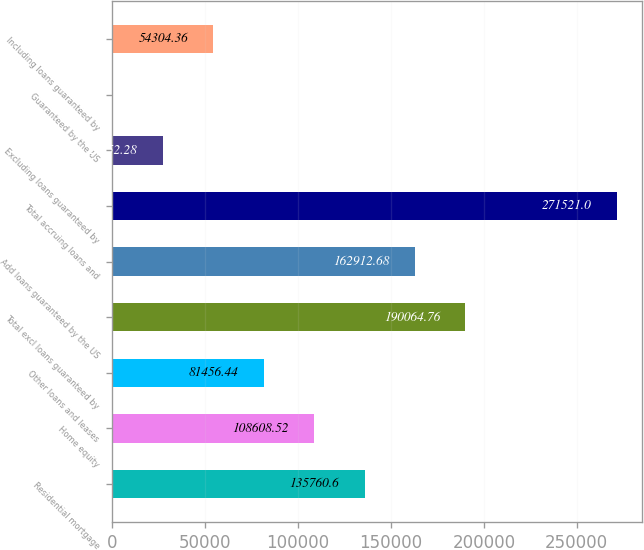Convert chart to OTSL. <chart><loc_0><loc_0><loc_500><loc_500><bar_chart><fcel>Residential mortgage<fcel>Home equity<fcel>Other loans and leases<fcel>Total excl loans guaranteed by<fcel>Add loans guaranteed by the US<fcel>Total accruing loans and<fcel>Excluding loans guaranteed by<fcel>Guaranteed by the US<fcel>Including loans guaranteed by<nl><fcel>135761<fcel>108609<fcel>81456.4<fcel>190065<fcel>162913<fcel>271521<fcel>27152.3<fcel>0.2<fcel>54304.4<nl></chart> 